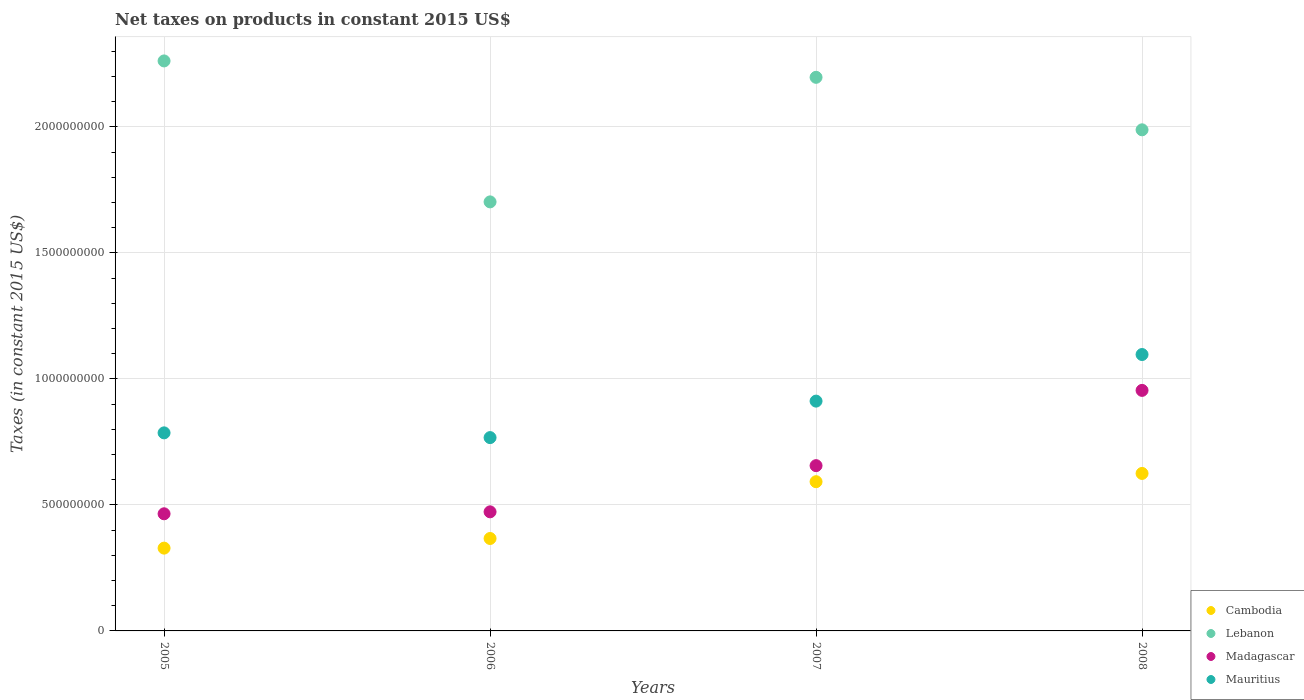How many different coloured dotlines are there?
Offer a terse response. 4. Is the number of dotlines equal to the number of legend labels?
Keep it short and to the point. Yes. What is the net taxes on products in Mauritius in 2006?
Give a very brief answer. 7.67e+08. Across all years, what is the maximum net taxes on products in Madagascar?
Provide a short and direct response. 9.54e+08. Across all years, what is the minimum net taxes on products in Mauritius?
Your answer should be very brief. 7.67e+08. In which year was the net taxes on products in Lebanon minimum?
Make the answer very short. 2006. What is the total net taxes on products in Lebanon in the graph?
Keep it short and to the point. 8.15e+09. What is the difference between the net taxes on products in Cambodia in 2006 and that in 2008?
Give a very brief answer. -2.58e+08. What is the difference between the net taxes on products in Lebanon in 2006 and the net taxes on products in Mauritius in 2007?
Offer a very short reply. 7.90e+08. What is the average net taxes on products in Mauritius per year?
Give a very brief answer. 8.90e+08. In the year 2007, what is the difference between the net taxes on products in Madagascar and net taxes on products in Cambodia?
Give a very brief answer. 6.37e+07. In how many years, is the net taxes on products in Mauritius greater than 2000000000 US$?
Your answer should be very brief. 0. What is the ratio of the net taxes on products in Madagascar in 2005 to that in 2007?
Provide a succinct answer. 0.71. Is the net taxes on products in Mauritius in 2005 less than that in 2006?
Your response must be concise. No. What is the difference between the highest and the second highest net taxes on products in Cambodia?
Keep it short and to the point. 3.27e+07. What is the difference between the highest and the lowest net taxes on products in Madagascar?
Provide a succinct answer. 4.90e+08. Is it the case that in every year, the sum of the net taxes on products in Cambodia and net taxes on products in Mauritius  is greater than the net taxes on products in Madagascar?
Your answer should be very brief. Yes. Does the net taxes on products in Lebanon monotonically increase over the years?
Provide a succinct answer. No. Is the net taxes on products in Cambodia strictly greater than the net taxes on products in Madagascar over the years?
Your answer should be very brief. No. How many dotlines are there?
Offer a very short reply. 4. Are the values on the major ticks of Y-axis written in scientific E-notation?
Your response must be concise. No. How many legend labels are there?
Make the answer very short. 4. How are the legend labels stacked?
Provide a succinct answer. Vertical. What is the title of the graph?
Offer a terse response. Net taxes on products in constant 2015 US$. What is the label or title of the X-axis?
Your answer should be compact. Years. What is the label or title of the Y-axis?
Your answer should be compact. Taxes (in constant 2015 US$). What is the Taxes (in constant 2015 US$) of Cambodia in 2005?
Your answer should be compact. 3.28e+08. What is the Taxes (in constant 2015 US$) of Lebanon in 2005?
Give a very brief answer. 2.26e+09. What is the Taxes (in constant 2015 US$) of Madagascar in 2005?
Your response must be concise. 4.65e+08. What is the Taxes (in constant 2015 US$) of Mauritius in 2005?
Your answer should be compact. 7.86e+08. What is the Taxes (in constant 2015 US$) in Cambodia in 2006?
Offer a terse response. 3.67e+08. What is the Taxes (in constant 2015 US$) in Lebanon in 2006?
Provide a short and direct response. 1.70e+09. What is the Taxes (in constant 2015 US$) in Madagascar in 2006?
Provide a short and direct response. 4.72e+08. What is the Taxes (in constant 2015 US$) in Mauritius in 2006?
Offer a very short reply. 7.67e+08. What is the Taxes (in constant 2015 US$) of Cambodia in 2007?
Offer a very short reply. 5.92e+08. What is the Taxes (in constant 2015 US$) of Lebanon in 2007?
Your response must be concise. 2.20e+09. What is the Taxes (in constant 2015 US$) of Madagascar in 2007?
Offer a very short reply. 6.56e+08. What is the Taxes (in constant 2015 US$) of Mauritius in 2007?
Your response must be concise. 9.12e+08. What is the Taxes (in constant 2015 US$) of Cambodia in 2008?
Ensure brevity in your answer.  6.25e+08. What is the Taxes (in constant 2015 US$) in Lebanon in 2008?
Provide a succinct answer. 1.99e+09. What is the Taxes (in constant 2015 US$) of Madagascar in 2008?
Provide a short and direct response. 9.54e+08. What is the Taxes (in constant 2015 US$) of Mauritius in 2008?
Provide a short and direct response. 1.10e+09. Across all years, what is the maximum Taxes (in constant 2015 US$) of Cambodia?
Your response must be concise. 6.25e+08. Across all years, what is the maximum Taxes (in constant 2015 US$) in Lebanon?
Ensure brevity in your answer.  2.26e+09. Across all years, what is the maximum Taxes (in constant 2015 US$) of Madagascar?
Provide a short and direct response. 9.54e+08. Across all years, what is the maximum Taxes (in constant 2015 US$) in Mauritius?
Your response must be concise. 1.10e+09. Across all years, what is the minimum Taxes (in constant 2015 US$) of Cambodia?
Ensure brevity in your answer.  3.28e+08. Across all years, what is the minimum Taxes (in constant 2015 US$) of Lebanon?
Your answer should be very brief. 1.70e+09. Across all years, what is the minimum Taxes (in constant 2015 US$) of Madagascar?
Offer a terse response. 4.65e+08. Across all years, what is the minimum Taxes (in constant 2015 US$) of Mauritius?
Your answer should be very brief. 7.67e+08. What is the total Taxes (in constant 2015 US$) of Cambodia in the graph?
Make the answer very short. 1.91e+09. What is the total Taxes (in constant 2015 US$) in Lebanon in the graph?
Make the answer very short. 8.15e+09. What is the total Taxes (in constant 2015 US$) in Madagascar in the graph?
Offer a terse response. 2.55e+09. What is the total Taxes (in constant 2015 US$) in Mauritius in the graph?
Your response must be concise. 3.56e+09. What is the difference between the Taxes (in constant 2015 US$) of Cambodia in 2005 and that in 2006?
Your answer should be compact. -3.82e+07. What is the difference between the Taxes (in constant 2015 US$) in Lebanon in 2005 and that in 2006?
Offer a very short reply. 5.59e+08. What is the difference between the Taxes (in constant 2015 US$) of Madagascar in 2005 and that in 2006?
Your answer should be very brief. -7.75e+06. What is the difference between the Taxes (in constant 2015 US$) of Mauritius in 2005 and that in 2006?
Offer a terse response. 1.88e+07. What is the difference between the Taxes (in constant 2015 US$) of Cambodia in 2005 and that in 2007?
Provide a succinct answer. -2.64e+08. What is the difference between the Taxes (in constant 2015 US$) in Lebanon in 2005 and that in 2007?
Offer a terse response. 6.50e+07. What is the difference between the Taxes (in constant 2015 US$) in Madagascar in 2005 and that in 2007?
Offer a very short reply. -1.91e+08. What is the difference between the Taxes (in constant 2015 US$) in Mauritius in 2005 and that in 2007?
Your response must be concise. -1.26e+08. What is the difference between the Taxes (in constant 2015 US$) of Cambodia in 2005 and that in 2008?
Keep it short and to the point. -2.96e+08. What is the difference between the Taxes (in constant 2015 US$) of Lebanon in 2005 and that in 2008?
Offer a very short reply. 2.73e+08. What is the difference between the Taxes (in constant 2015 US$) in Madagascar in 2005 and that in 2008?
Provide a succinct answer. -4.90e+08. What is the difference between the Taxes (in constant 2015 US$) in Mauritius in 2005 and that in 2008?
Give a very brief answer. -3.11e+08. What is the difference between the Taxes (in constant 2015 US$) of Cambodia in 2006 and that in 2007?
Your answer should be compact. -2.25e+08. What is the difference between the Taxes (in constant 2015 US$) in Lebanon in 2006 and that in 2007?
Make the answer very short. -4.94e+08. What is the difference between the Taxes (in constant 2015 US$) of Madagascar in 2006 and that in 2007?
Your answer should be compact. -1.83e+08. What is the difference between the Taxes (in constant 2015 US$) of Mauritius in 2006 and that in 2007?
Keep it short and to the point. -1.45e+08. What is the difference between the Taxes (in constant 2015 US$) of Cambodia in 2006 and that in 2008?
Keep it short and to the point. -2.58e+08. What is the difference between the Taxes (in constant 2015 US$) of Lebanon in 2006 and that in 2008?
Offer a very short reply. -2.86e+08. What is the difference between the Taxes (in constant 2015 US$) in Madagascar in 2006 and that in 2008?
Make the answer very short. -4.82e+08. What is the difference between the Taxes (in constant 2015 US$) in Mauritius in 2006 and that in 2008?
Your answer should be very brief. -3.30e+08. What is the difference between the Taxes (in constant 2015 US$) of Cambodia in 2007 and that in 2008?
Keep it short and to the point. -3.27e+07. What is the difference between the Taxes (in constant 2015 US$) of Lebanon in 2007 and that in 2008?
Make the answer very short. 2.08e+08. What is the difference between the Taxes (in constant 2015 US$) in Madagascar in 2007 and that in 2008?
Make the answer very short. -2.99e+08. What is the difference between the Taxes (in constant 2015 US$) of Mauritius in 2007 and that in 2008?
Provide a succinct answer. -1.85e+08. What is the difference between the Taxes (in constant 2015 US$) of Cambodia in 2005 and the Taxes (in constant 2015 US$) of Lebanon in 2006?
Give a very brief answer. -1.37e+09. What is the difference between the Taxes (in constant 2015 US$) in Cambodia in 2005 and the Taxes (in constant 2015 US$) in Madagascar in 2006?
Ensure brevity in your answer.  -1.44e+08. What is the difference between the Taxes (in constant 2015 US$) in Cambodia in 2005 and the Taxes (in constant 2015 US$) in Mauritius in 2006?
Offer a terse response. -4.38e+08. What is the difference between the Taxes (in constant 2015 US$) in Lebanon in 2005 and the Taxes (in constant 2015 US$) in Madagascar in 2006?
Your response must be concise. 1.79e+09. What is the difference between the Taxes (in constant 2015 US$) in Lebanon in 2005 and the Taxes (in constant 2015 US$) in Mauritius in 2006?
Ensure brevity in your answer.  1.49e+09. What is the difference between the Taxes (in constant 2015 US$) in Madagascar in 2005 and the Taxes (in constant 2015 US$) in Mauritius in 2006?
Offer a very short reply. -3.02e+08. What is the difference between the Taxes (in constant 2015 US$) of Cambodia in 2005 and the Taxes (in constant 2015 US$) of Lebanon in 2007?
Your answer should be very brief. -1.87e+09. What is the difference between the Taxes (in constant 2015 US$) in Cambodia in 2005 and the Taxes (in constant 2015 US$) in Madagascar in 2007?
Keep it short and to the point. -3.27e+08. What is the difference between the Taxes (in constant 2015 US$) of Cambodia in 2005 and the Taxes (in constant 2015 US$) of Mauritius in 2007?
Provide a succinct answer. -5.83e+08. What is the difference between the Taxes (in constant 2015 US$) in Lebanon in 2005 and the Taxes (in constant 2015 US$) in Madagascar in 2007?
Offer a terse response. 1.61e+09. What is the difference between the Taxes (in constant 2015 US$) in Lebanon in 2005 and the Taxes (in constant 2015 US$) in Mauritius in 2007?
Keep it short and to the point. 1.35e+09. What is the difference between the Taxes (in constant 2015 US$) of Madagascar in 2005 and the Taxes (in constant 2015 US$) of Mauritius in 2007?
Provide a short and direct response. -4.47e+08. What is the difference between the Taxes (in constant 2015 US$) of Cambodia in 2005 and the Taxes (in constant 2015 US$) of Lebanon in 2008?
Offer a very short reply. -1.66e+09. What is the difference between the Taxes (in constant 2015 US$) in Cambodia in 2005 and the Taxes (in constant 2015 US$) in Madagascar in 2008?
Provide a short and direct response. -6.26e+08. What is the difference between the Taxes (in constant 2015 US$) of Cambodia in 2005 and the Taxes (in constant 2015 US$) of Mauritius in 2008?
Provide a short and direct response. -7.68e+08. What is the difference between the Taxes (in constant 2015 US$) in Lebanon in 2005 and the Taxes (in constant 2015 US$) in Madagascar in 2008?
Offer a very short reply. 1.31e+09. What is the difference between the Taxes (in constant 2015 US$) of Lebanon in 2005 and the Taxes (in constant 2015 US$) of Mauritius in 2008?
Provide a succinct answer. 1.16e+09. What is the difference between the Taxes (in constant 2015 US$) of Madagascar in 2005 and the Taxes (in constant 2015 US$) of Mauritius in 2008?
Ensure brevity in your answer.  -6.32e+08. What is the difference between the Taxes (in constant 2015 US$) in Cambodia in 2006 and the Taxes (in constant 2015 US$) in Lebanon in 2007?
Keep it short and to the point. -1.83e+09. What is the difference between the Taxes (in constant 2015 US$) in Cambodia in 2006 and the Taxes (in constant 2015 US$) in Madagascar in 2007?
Provide a succinct answer. -2.89e+08. What is the difference between the Taxes (in constant 2015 US$) in Cambodia in 2006 and the Taxes (in constant 2015 US$) in Mauritius in 2007?
Provide a succinct answer. -5.45e+08. What is the difference between the Taxes (in constant 2015 US$) in Lebanon in 2006 and the Taxes (in constant 2015 US$) in Madagascar in 2007?
Your answer should be compact. 1.05e+09. What is the difference between the Taxes (in constant 2015 US$) of Lebanon in 2006 and the Taxes (in constant 2015 US$) of Mauritius in 2007?
Your answer should be very brief. 7.90e+08. What is the difference between the Taxes (in constant 2015 US$) of Madagascar in 2006 and the Taxes (in constant 2015 US$) of Mauritius in 2007?
Your answer should be very brief. -4.39e+08. What is the difference between the Taxes (in constant 2015 US$) of Cambodia in 2006 and the Taxes (in constant 2015 US$) of Lebanon in 2008?
Provide a succinct answer. -1.62e+09. What is the difference between the Taxes (in constant 2015 US$) of Cambodia in 2006 and the Taxes (in constant 2015 US$) of Madagascar in 2008?
Offer a very short reply. -5.88e+08. What is the difference between the Taxes (in constant 2015 US$) in Cambodia in 2006 and the Taxes (in constant 2015 US$) in Mauritius in 2008?
Keep it short and to the point. -7.30e+08. What is the difference between the Taxes (in constant 2015 US$) in Lebanon in 2006 and the Taxes (in constant 2015 US$) in Madagascar in 2008?
Your answer should be compact. 7.48e+08. What is the difference between the Taxes (in constant 2015 US$) in Lebanon in 2006 and the Taxes (in constant 2015 US$) in Mauritius in 2008?
Provide a short and direct response. 6.06e+08. What is the difference between the Taxes (in constant 2015 US$) of Madagascar in 2006 and the Taxes (in constant 2015 US$) of Mauritius in 2008?
Give a very brief answer. -6.24e+08. What is the difference between the Taxes (in constant 2015 US$) in Cambodia in 2007 and the Taxes (in constant 2015 US$) in Lebanon in 2008?
Your answer should be compact. -1.40e+09. What is the difference between the Taxes (in constant 2015 US$) of Cambodia in 2007 and the Taxes (in constant 2015 US$) of Madagascar in 2008?
Give a very brief answer. -3.62e+08. What is the difference between the Taxes (in constant 2015 US$) of Cambodia in 2007 and the Taxes (in constant 2015 US$) of Mauritius in 2008?
Make the answer very short. -5.05e+08. What is the difference between the Taxes (in constant 2015 US$) of Lebanon in 2007 and the Taxes (in constant 2015 US$) of Madagascar in 2008?
Ensure brevity in your answer.  1.24e+09. What is the difference between the Taxes (in constant 2015 US$) of Lebanon in 2007 and the Taxes (in constant 2015 US$) of Mauritius in 2008?
Your response must be concise. 1.10e+09. What is the difference between the Taxes (in constant 2015 US$) of Madagascar in 2007 and the Taxes (in constant 2015 US$) of Mauritius in 2008?
Make the answer very short. -4.41e+08. What is the average Taxes (in constant 2015 US$) of Cambodia per year?
Offer a very short reply. 4.78e+08. What is the average Taxes (in constant 2015 US$) of Lebanon per year?
Keep it short and to the point. 2.04e+09. What is the average Taxes (in constant 2015 US$) in Madagascar per year?
Provide a short and direct response. 6.37e+08. What is the average Taxes (in constant 2015 US$) in Mauritius per year?
Keep it short and to the point. 8.90e+08. In the year 2005, what is the difference between the Taxes (in constant 2015 US$) in Cambodia and Taxes (in constant 2015 US$) in Lebanon?
Offer a very short reply. -1.93e+09. In the year 2005, what is the difference between the Taxes (in constant 2015 US$) of Cambodia and Taxes (in constant 2015 US$) of Madagascar?
Offer a very short reply. -1.36e+08. In the year 2005, what is the difference between the Taxes (in constant 2015 US$) of Cambodia and Taxes (in constant 2015 US$) of Mauritius?
Give a very brief answer. -4.57e+08. In the year 2005, what is the difference between the Taxes (in constant 2015 US$) in Lebanon and Taxes (in constant 2015 US$) in Madagascar?
Offer a terse response. 1.80e+09. In the year 2005, what is the difference between the Taxes (in constant 2015 US$) in Lebanon and Taxes (in constant 2015 US$) in Mauritius?
Keep it short and to the point. 1.48e+09. In the year 2005, what is the difference between the Taxes (in constant 2015 US$) in Madagascar and Taxes (in constant 2015 US$) in Mauritius?
Provide a short and direct response. -3.21e+08. In the year 2006, what is the difference between the Taxes (in constant 2015 US$) in Cambodia and Taxes (in constant 2015 US$) in Lebanon?
Provide a succinct answer. -1.34e+09. In the year 2006, what is the difference between the Taxes (in constant 2015 US$) in Cambodia and Taxes (in constant 2015 US$) in Madagascar?
Make the answer very short. -1.06e+08. In the year 2006, what is the difference between the Taxes (in constant 2015 US$) of Cambodia and Taxes (in constant 2015 US$) of Mauritius?
Your answer should be compact. -4.00e+08. In the year 2006, what is the difference between the Taxes (in constant 2015 US$) of Lebanon and Taxes (in constant 2015 US$) of Madagascar?
Give a very brief answer. 1.23e+09. In the year 2006, what is the difference between the Taxes (in constant 2015 US$) of Lebanon and Taxes (in constant 2015 US$) of Mauritius?
Give a very brief answer. 9.35e+08. In the year 2006, what is the difference between the Taxes (in constant 2015 US$) of Madagascar and Taxes (in constant 2015 US$) of Mauritius?
Offer a terse response. -2.95e+08. In the year 2007, what is the difference between the Taxes (in constant 2015 US$) of Cambodia and Taxes (in constant 2015 US$) of Lebanon?
Ensure brevity in your answer.  -1.60e+09. In the year 2007, what is the difference between the Taxes (in constant 2015 US$) of Cambodia and Taxes (in constant 2015 US$) of Madagascar?
Make the answer very short. -6.37e+07. In the year 2007, what is the difference between the Taxes (in constant 2015 US$) in Cambodia and Taxes (in constant 2015 US$) in Mauritius?
Offer a very short reply. -3.20e+08. In the year 2007, what is the difference between the Taxes (in constant 2015 US$) in Lebanon and Taxes (in constant 2015 US$) in Madagascar?
Provide a short and direct response. 1.54e+09. In the year 2007, what is the difference between the Taxes (in constant 2015 US$) in Lebanon and Taxes (in constant 2015 US$) in Mauritius?
Ensure brevity in your answer.  1.28e+09. In the year 2007, what is the difference between the Taxes (in constant 2015 US$) of Madagascar and Taxes (in constant 2015 US$) of Mauritius?
Your answer should be very brief. -2.56e+08. In the year 2008, what is the difference between the Taxes (in constant 2015 US$) in Cambodia and Taxes (in constant 2015 US$) in Lebanon?
Offer a terse response. -1.36e+09. In the year 2008, what is the difference between the Taxes (in constant 2015 US$) in Cambodia and Taxes (in constant 2015 US$) in Madagascar?
Offer a very short reply. -3.29e+08. In the year 2008, what is the difference between the Taxes (in constant 2015 US$) in Cambodia and Taxes (in constant 2015 US$) in Mauritius?
Your answer should be compact. -4.72e+08. In the year 2008, what is the difference between the Taxes (in constant 2015 US$) in Lebanon and Taxes (in constant 2015 US$) in Madagascar?
Provide a succinct answer. 1.03e+09. In the year 2008, what is the difference between the Taxes (in constant 2015 US$) in Lebanon and Taxes (in constant 2015 US$) in Mauritius?
Provide a succinct answer. 8.91e+08. In the year 2008, what is the difference between the Taxes (in constant 2015 US$) of Madagascar and Taxes (in constant 2015 US$) of Mauritius?
Offer a very short reply. -1.42e+08. What is the ratio of the Taxes (in constant 2015 US$) in Cambodia in 2005 to that in 2006?
Provide a short and direct response. 0.9. What is the ratio of the Taxes (in constant 2015 US$) of Lebanon in 2005 to that in 2006?
Ensure brevity in your answer.  1.33. What is the ratio of the Taxes (in constant 2015 US$) in Madagascar in 2005 to that in 2006?
Offer a terse response. 0.98. What is the ratio of the Taxes (in constant 2015 US$) in Mauritius in 2005 to that in 2006?
Make the answer very short. 1.02. What is the ratio of the Taxes (in constant 2015 US$) of Cambodia in 2005 to that in 2007?
Your response must be concise. 0.55. What is the ratio of the Taxes (in constant 2015 US$) of Lebanon in 2005 to that in 2007?
Offer a very short reply. 1.03. What is the ratio of the Taxes (in constant 2015 US$) in Madagascar in 2005 to that in 2007?
Your answer should be compact. 0.71. What is the ratio of the Taxes (in constant 2015 US$) of Mauritius in 2005 to that in 2007?
Keep it short and to the point. 0.86. What is the ratio of the Taxes (in constant 2015 US$) in Cambodia in 2005 to that in 2008?
Give a very brief answer. 0.53. What is the ratio of the Taxes (in constant 2015 US$) in Lebanon in 2005 to that in 2008?
Offer a very short reply. 1.14. What is the ratio of the Taxes (in constant 2015 US$) in Madagascar in 2005 to that in 2008?
Offer a terse response. 0.49. What is the ratio of the Taxes (in constant 2015 US$) in Mauritius in 2005 to that in 2008?
Offer a very short reply. 0.72. What is the ratio of the Taxes (in constant 2015 US$) in Cambodia in 2006 to that in 2007?
Provide a succinct answer. 0.62. What is the ratio of the Taxes (in constant 2015 US$) in Lebanon in 2006 to that in 2007?
Provide a succinct answer. 0.78. What is the ratio of the Taxes (in constant 2015 US$) in Madagascar in 2006 to that in 2007?
Keep it short and to the point. 0.72. What is the ratio of the Taxes (in constant 2015 US$) of Mauritius in 2006 to that in 2007?
Ensure brevity in your answer.  0.84. What is the ratio of the Taxes (in constant 2015 US$) of Cambodia in 2006 to that in 2008?
Offer a very short reply. 0.59. What is the ratio of the Taxes (in constant 2015 US$) in Lebanon in 2006 to that in 2008?
Keep it short and to the point. 0.86. What is the ratio of the Taxes (in constant 2015 US$) in Madagascar in 2006 to that in 2008?
Give a very brief answer. 0.5. What is the ratio of the Taxes (in constant 2015 US$) of Mauritius in 2006 to that in 2008?
Give a very brief answer. 0.7. What is the ratio of the Taxes (in constant 2015 US$) in Cambodia in 2007 to that in 2008?
Offer a very short reply. 0.95. What is the ratio of the Taxes (in constant 2015 US$) in Lebanon in 2007 to that in 2008?
Ensure brevity in your answer.  1.1. What is the ratio of the Taxes (in constant 2015 US$) of Madagascar in 2007 to that in 2008?
Give a very brief answer. 0.69. What is the ratio of the Taxes (in constant 2015 US$) of Mauritius in 2007 to that in 2008?
Make the answer very short. 0.83. What is the difference between the highest and the second highest Taxes (in constant 2015 US$) in Cambodia?
Give a very brief answer. 3.27e+07. What is the difference between the highest and the second highest Taxes (in constant 2015 US$) in Lebanon?
Your answer should be very brief. 6.50e+07. What is the difference between the highest and the second highest Taxes (in constant 2015 US$) of Madagascar?
Provide a short and direct response. 2.99e+08. What is the difference between the highest and the second highest Taxes (in constant 2015 US$) in Mauritius?
Make the answer very short. 1.85e+08. What is the difference between the highest and the lowest Taxes (in constant 2015 US$) in Cambodia?
Your answer should be very brief. 2.96e+08. What is the difference between the highest and the lowest Taxes (in constant 2015 US$) in Lebanon?
Provide a succinct answer. 5.59e+08. What is the difference between the highest and the lowest Taxes (in constant 2015 US$) of Madagascar?
Your answer should be very brief. 4.90e+08. What is the difference between the highest and the lowest Taxes (in constant 2015 US$) in Mauritius?
Your response must be concise. 3.30e+08. 